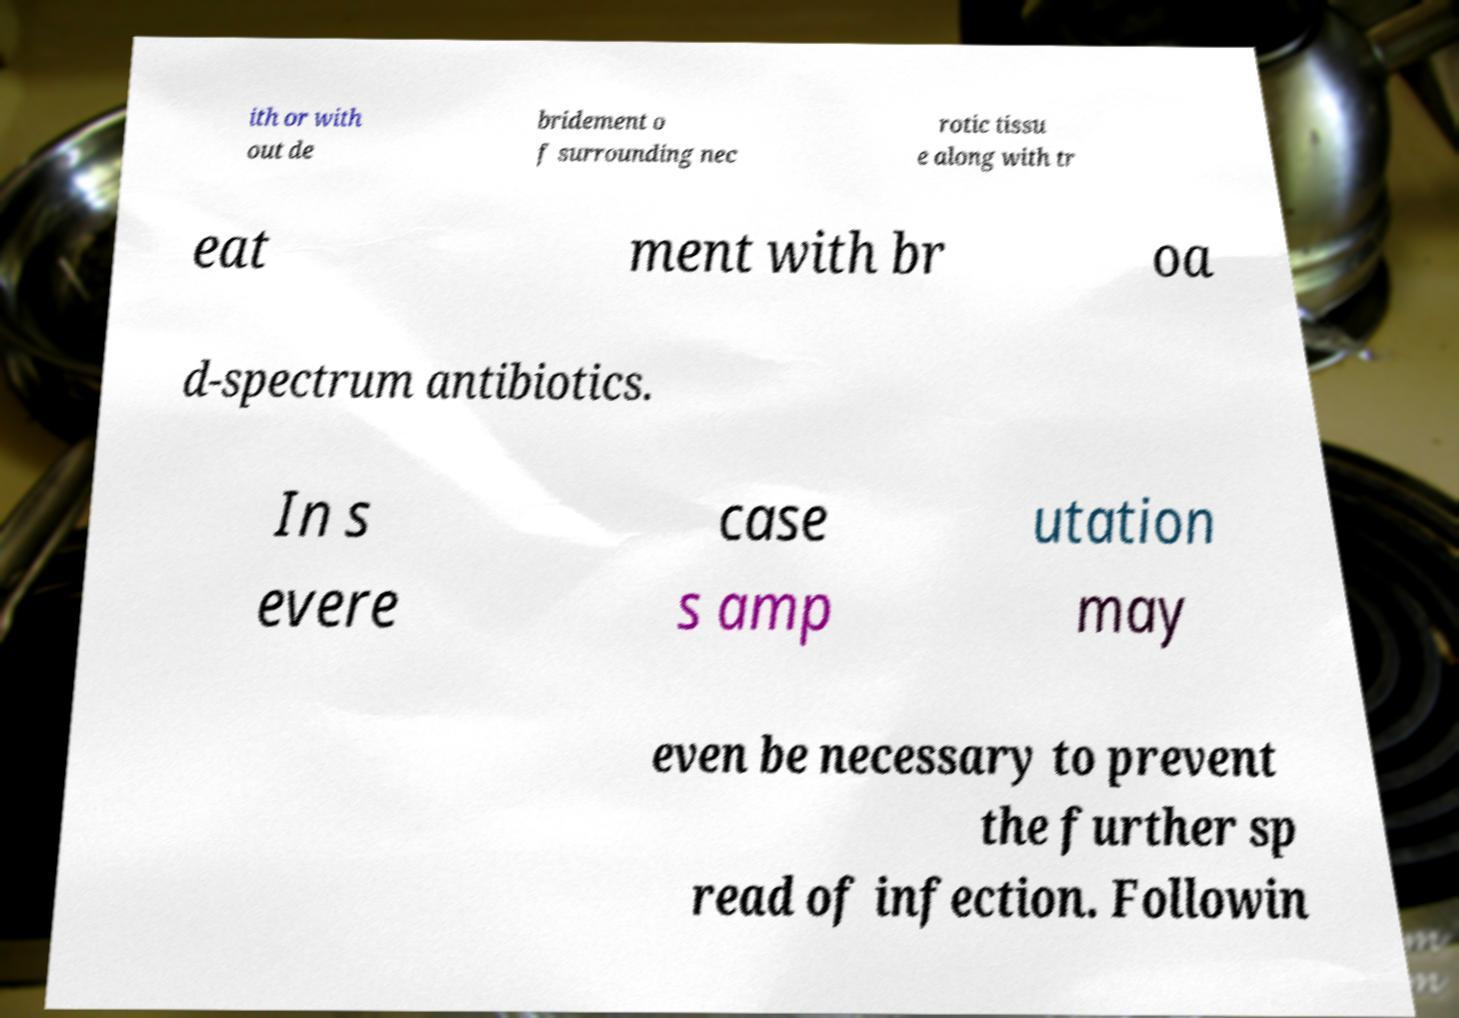Can you accurately transcribe the text from the provided image for me? ith or with out de bridement o f surrounding nec rotic tissu e along with tr eat ment with br oa d-spectrum antibiotics. In s evere case s amp utation may even be necessary to prevent the further sp read of infection. Followin 